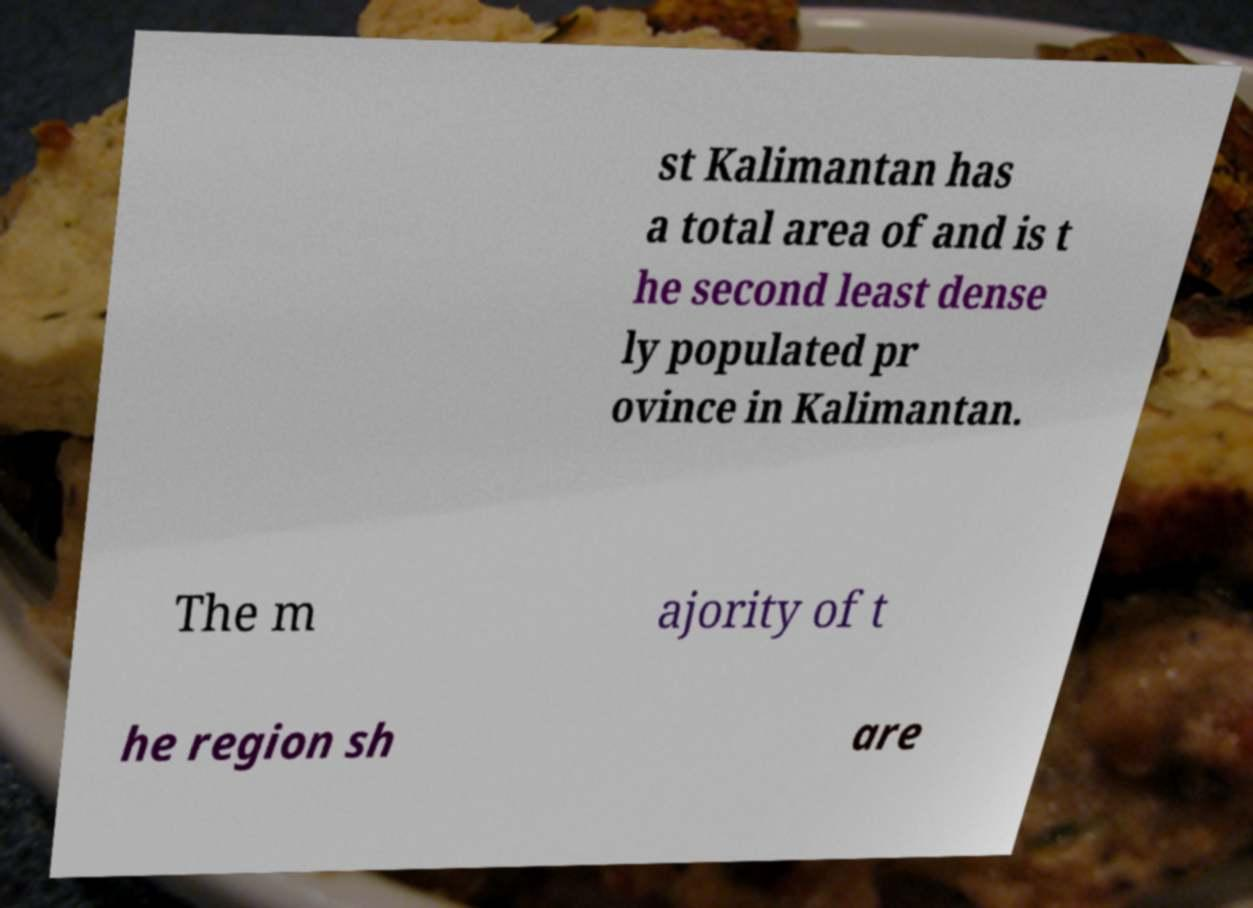Can you read and provide the text displayed in the image?This photo seems to have some interesting text. Can you extract and type it out for me? st Kalimantan has a total area of and is t he second least dense ly populated pr ovince in Kalimantan. The m ajority of t he region sh are 